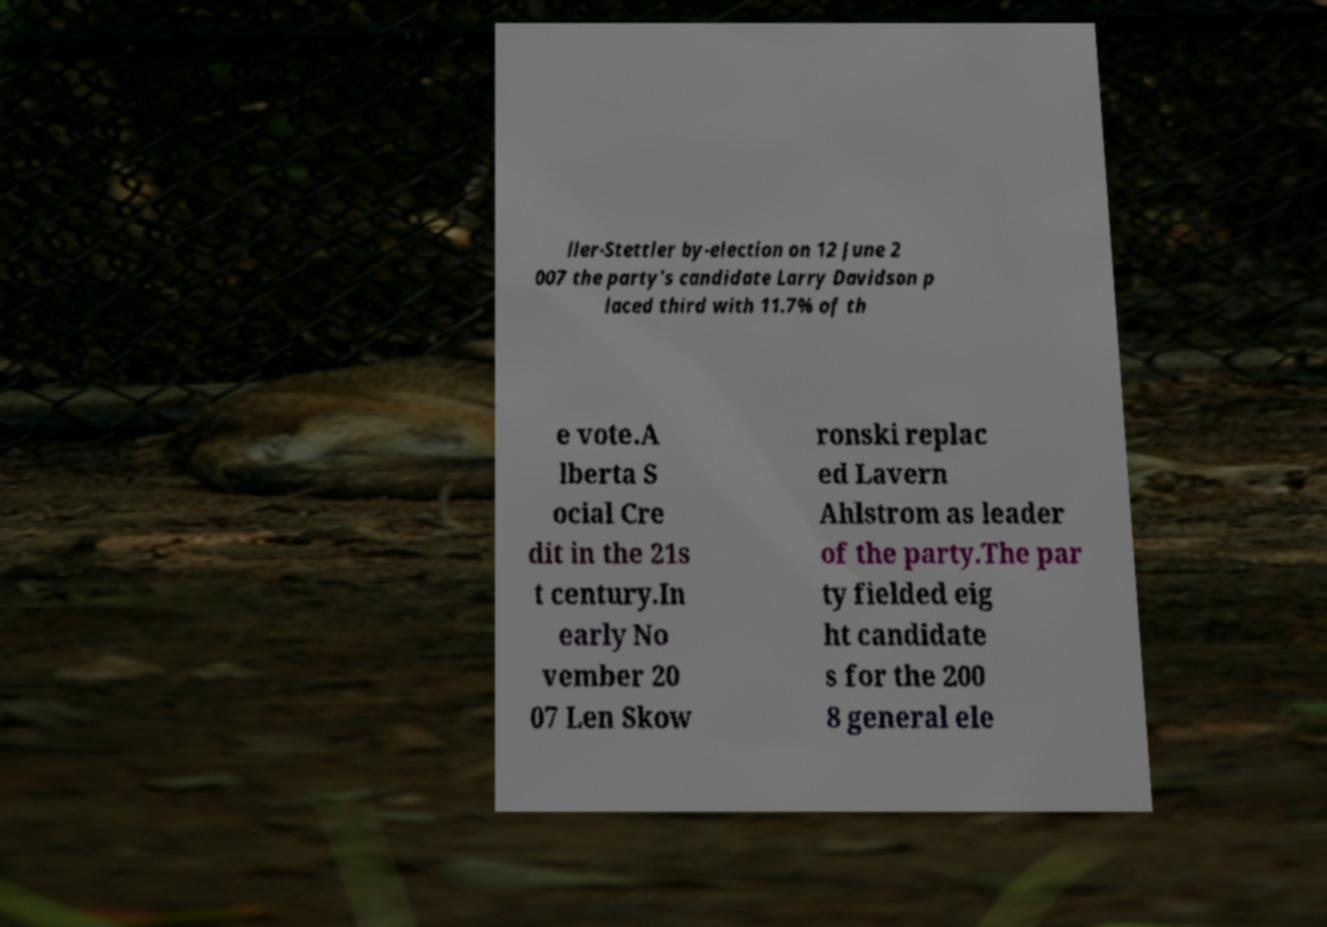There's text embedded in this image that I need extracted. Can you transcribe it verbatim? ller-Stettler by-election on 12 June 2 007 the party's candidate Larry Davidson p laced third with 11.7% of th e vote.A lberta S ocial Cre dit in the 21s t century.In early No vember 20 07 Len Skow ronski replac ed Lavern Ahlstrom as leader of the party.The par ty fielded eig ht candidate s for the 200 8 general ele 